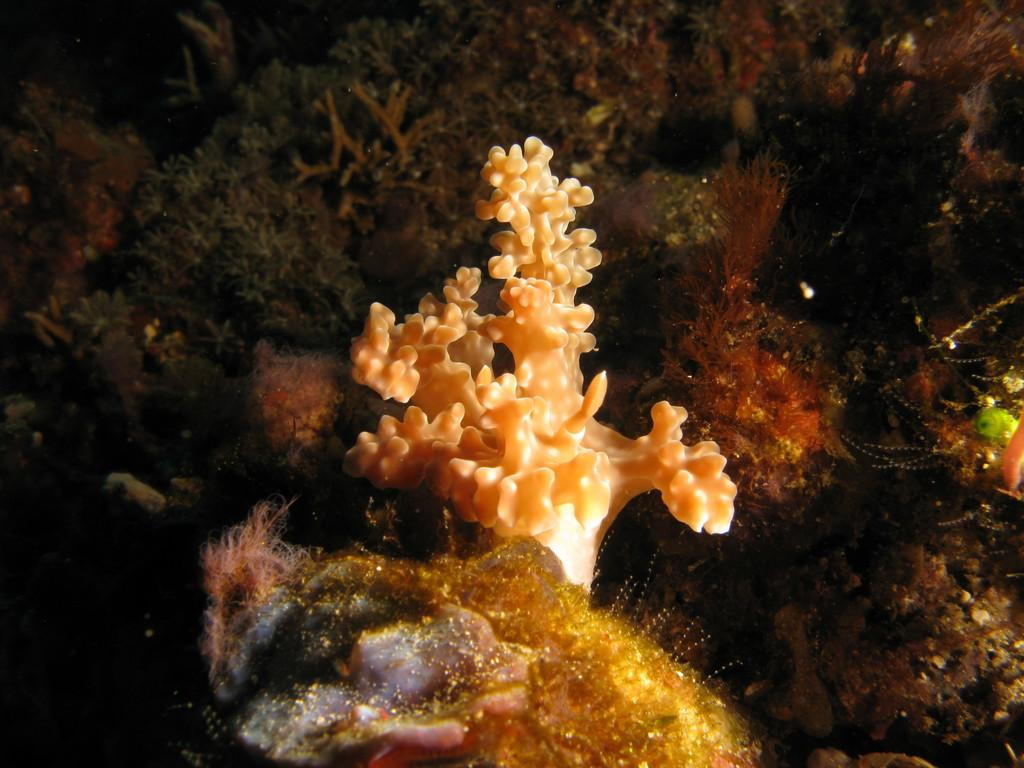What type of environment is depicted in the image? The image features coral and marine biology plants, indicating an underwater or aquatic environment. Can you describe the main object in the center of the image? There is a white object in the center of the image, but its specific nature is not clear from the provided facts. What type of arch can be seen in the image? There is no arch present in the image; it features coral and marine biology plants in an underwater or aquatic environment. What kind of fowl is swimming among the coral in the image? There is no fowl present in the image; it features coral and marine biology plants in an underwater or aquatic environment. 